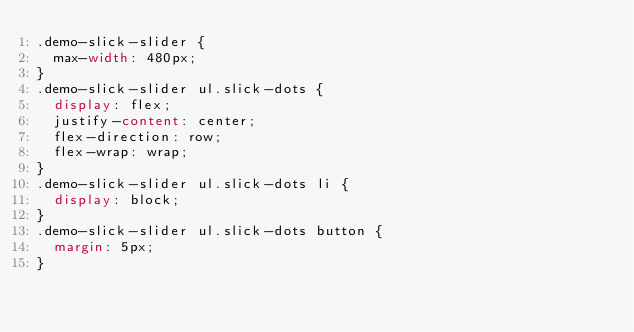Convert code to text. <code><loc_0><loc_0><loc_500><loc_500><_CSS_>.demo-slick-slider {
  max-width: 480px;
}
.demo-slick-slider ul.slick-dots {
  display: flex;
  justify-content: center;
  flex-direction: row;
  flex-wrap: wrap;
}
.demo-slick-slider ul.slick-dots li {
  display: block;
}
.demo-slick-slider ul.slick-dots button {
  margin: 5px;
}
</code> 